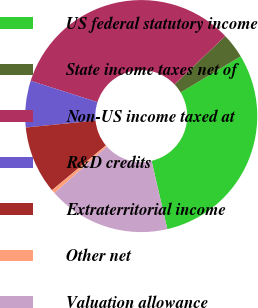Convert chart to OTSL. <chart><loc_0><loc_0><loc_500><loc_500><pie_chart><fcel>US federal statutory income<fcel>State income taxes net of<fcel>Non-US income taxed at<fcel>R&D credits<fcel>Extraterritorial income<fcel>Other net<fcel>Valuation allowance<nl><fcel>30.0%<fcel>3.5%<fcel>32.98%<fcel>6.48%<fcel>9.46%<fcel>0.51%<fcel>17.06%<nl></chart> 